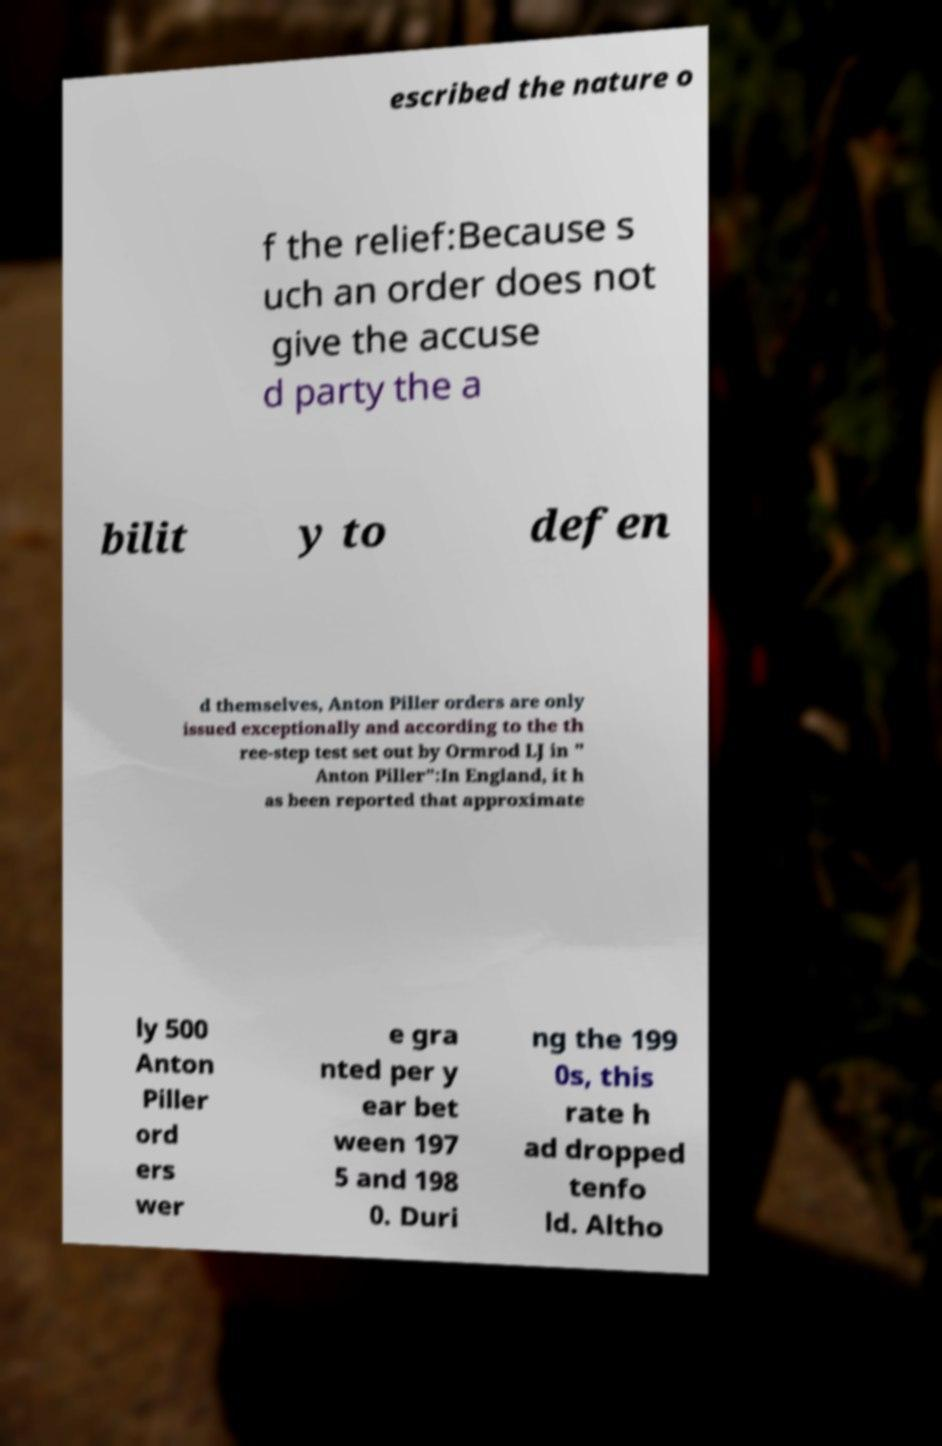I need the written content from this picture converted into text. Can you do that? escribed the nature o f the relief:Because s uch an order does not give the accuse d party the a bilit y to defen d themselves, Anton Piller orders are only issued exceptionally and according to the th ree-step test set out by Ormrod LJ in " Anton Piller":In England, it h as been reported that approximate ly 500 Anton Piller ord ers wer e gra nted per y ear bet ween 197 5 and 198 0. Duri ng the 199 0s, this rate h ad dropped tenfo ld. Altho 